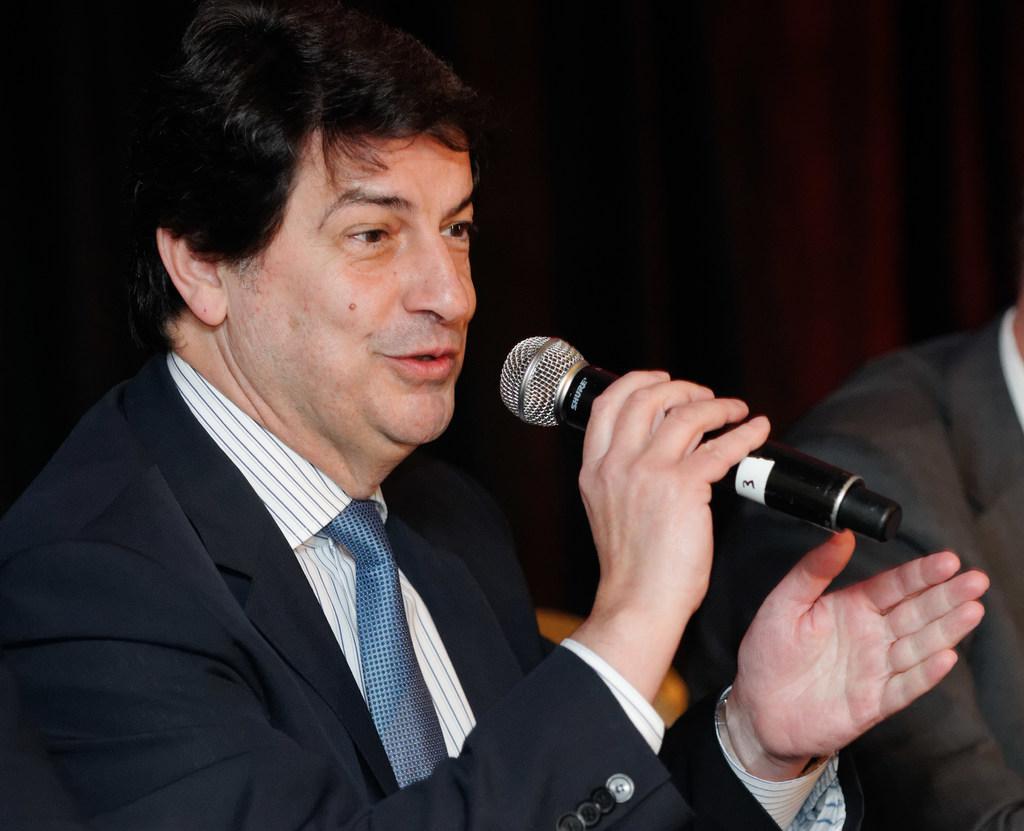Can you describe this image briefly? This person is holding a mic wore black suit and tie. Beside this person there is an another person in a black suit. 